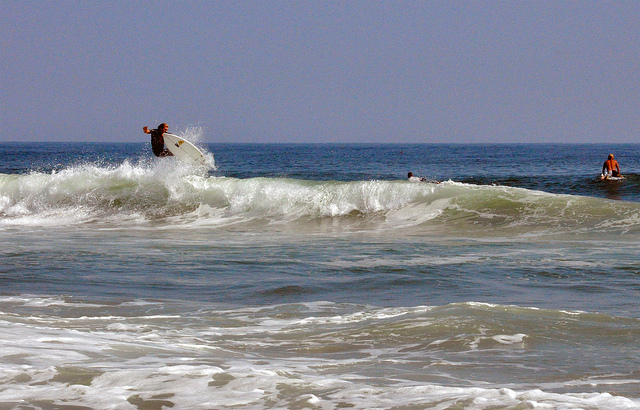<image>How deep is the water? It is unknown how deep the water is. It could range from being fairly shallow to various feet deep. How deep is the water? I don't know how deep the water is. It can be few feet, fairly shallow, deep, 15 feet, 4 feet or 10 feet. 